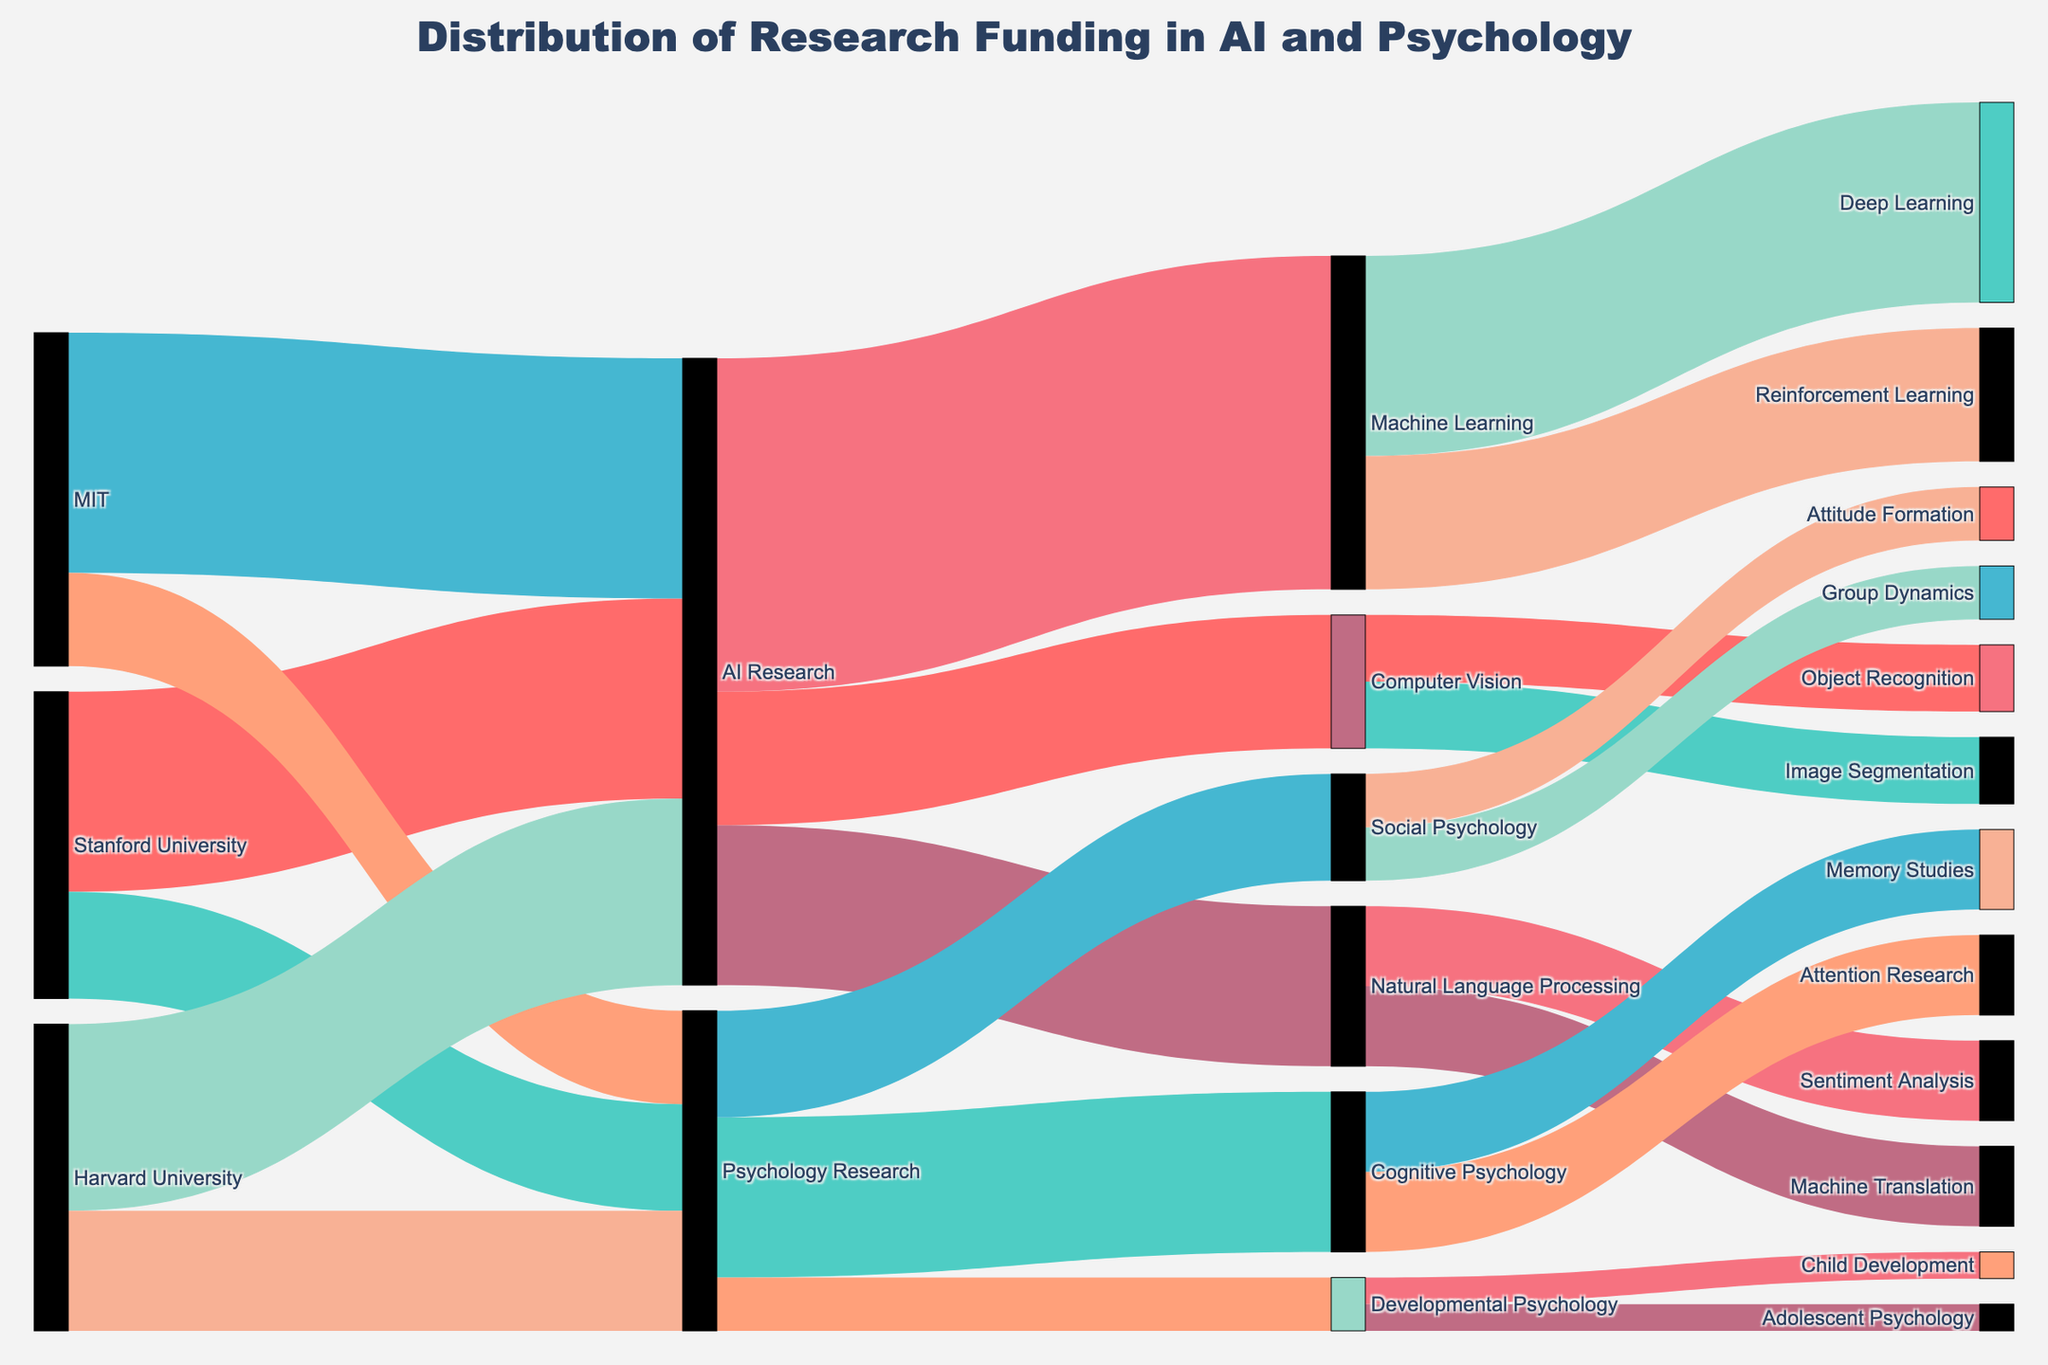What's the title of the figure? The title is usually located prominently at the top or in another easily visible area. Here, the title is "Distribution of Research Funding in AI and Psychology".
Answer: Distribution of Research Funding in AI and Psychology How much funding did Stanford University receive for AI Research? Identify the link from Stanford University to AI Research and read the value presented.
Answer: $15,000,000 Which university received the least funding for Psychology Research? Compare the funding values linked to Psychology Research from each university. Harvard University received $9,000,000, Stanford University received $8,000,000, and MIT received $7,000,000. So, MIT received the least funding.
Answer: MIT What is the total funding received by AI Research? Sum the amounts AI Research received from all universities. ($15,000,000 from Stanford, $18,000,000 from MIT, and $14,000,000 from Harvard): $15,000,000 + $18,000,000 + $14,000,000 = $47,000,000.
Answer: $47,000,000 Compare the total funding received by Psychology Research and AI Research. Which one received more? Calculate the total funding for both fields. AI Research: $47,000,000; Psychology Research: $8,000,000 + $7,000,000 + $9,000,000 = $24,000,000. AI Research received more funding.
Answer: AI Research Which sub-field of AI Research received the most funding? Identify the links that continue from AI Research to its sub-fields (Machine Learning, Natural Language Processing, Computer Vision) and find the one with the highest value: Machine Learning: $25,000,000, Natural Language Processing: $12,000,000, and Computer Vision: $10,000,000. Machine Learning received the most.
Answer: Machine Learning What's the difference between funding for Cognitive Psychology and Social Psychology? Compare the funding values for Cognitive Psychology and Social Psychology: Cognitive Psychology received $12,000,000 and Social Psychology received $8,000,000. The difference is $12,000,000 - $8,000,000 = $4,000,000.
Answer: $4,000,000 How much total funding was given to Developmental Psychology? Sum the funding from the sub-fields of Developmental Psychology: Child Development and Adolescent Psychology each received $2,000,000, so the total is $2,000,000 + $2,000,000 = $4,000,000.
Answer: $4,000,000 What percentage of the total AI Research funding was allocated to Deep Learning? First, find the total AI Research funding which is $47,000,000. Then, see that Deep Learning received $15,000,000. The percentage is (15,000,000 / 47,000,000) * 100 ≈ 31.91%.
Answer: ~31.91% Which specific sub-field in Psychology Research received the smallest funding amount? Identify the funding amounts for each sub-field under Psychology Research: Cognitive Psychology (Memory Studies: $6,000,000, Attention Research: $6,000,000), Social Psychology (Group Dynamics: $4,000,000, Attitude Formation: $4,000,000), Developmental Psychology (Child Development: $2,000,000, Adolescent Psychology: $2,000,000). Both Child Development and Adolescent Psychology received the smallest funding amount of $2,000,000 each.
Answer: Child Development and Adolescent Psychology 